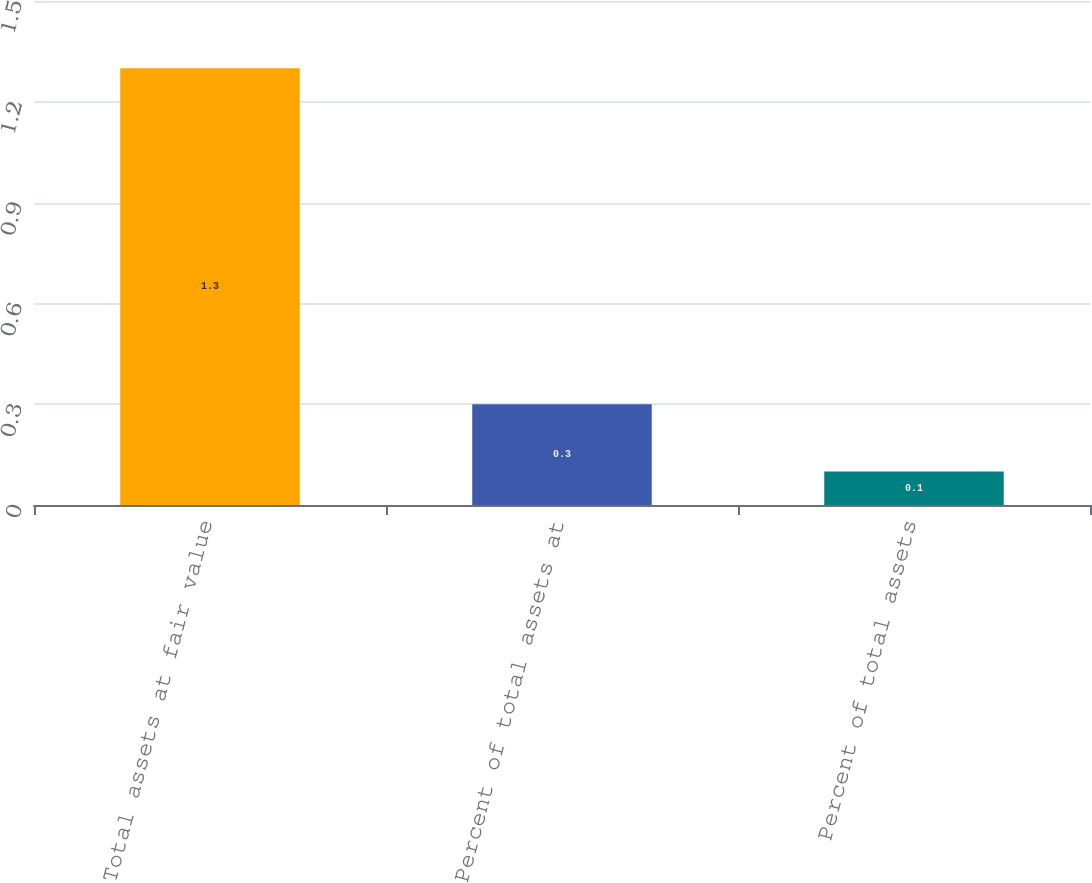Convert chart to OTSL. <chart><loc_0><loc_0><loc_500><loc_500><bar_chart><fcel>Total assets at fair value<fcel>Percent of total assets at<fcel>Percent of total assets<nl><fcel>1.3<fcel>0.3<fcel>0.1<nl></chart> 